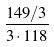Convert formula to latex. <formula><loc_0><loc_0><loc_500><loc_500>\frac { 1 4 9 / 3 } { 3 \cdot 1 1 8 }</formula> 